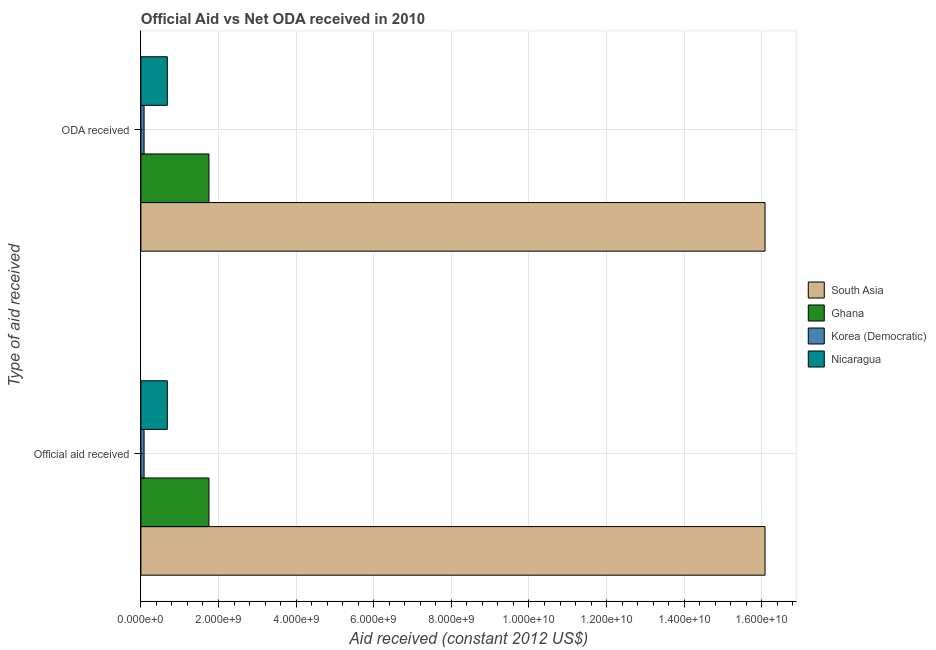How many different coloured bars are there?
Provide a succinct answer. 4. Are the number of bars per tick equal to the number of legend labels?
Provide a short and direct response. Yes. How many bars are there on the 1st tick from the top?
Give a very brief answer. 4. What is the label of the 2nd group of bars from the top?
Provide a succinct answer. Official aid received. What is the oda received in Nicaragua?
Your answer should be compact. 6.81e+08. Across all countries, what is the maximum official aid received?
Provide a succinct answer. 1.61e+1. Across all countries, what is the minimum oda received?
Provide a short and direct response. 8.22e+07. In which country was the oda received minimum?
Your answer should be very brief. Korea (Democratic). What is the total oda received in the graph?
Give a very brief answer. 1.86e+1. What is the difference between the official aid received in Ghana and that in Korea (Democratic)?
Give a very brief answer. 1.67e+09. What is the difference between the official aid received in Korea (Democratic) and the oda received in Nicaragua?
Offer a terse response. -5.99e+08. What is the average oda received per country?
Offer a terse response. 4.65e+09. What is the difference between the official aid received and oda received in Ghana?
Offer a very short reply. 0. What is the ratio of the oda received in Nicaragua to that in South Asia?
Keep it short and to the point. 0.04. In how many countries, is the official aid received greater than the average official aid received taken over all countries?
Offer a very short reply. 1. What does the 2nd bar from the top in ODA received represents?
Give a very brief answer. Korea (Democratic). How many countries are there in the graph?
Make the answer very short. 4. How many legend labels are there?
Keep it short and to the point. 4. What is the title of the graph?
Give a very brief answer. Official Aid vs Net ODA received in 2010 . What is the label or title of the X-axis?
Your answer should be very brief. Aid received (constant 2012 US$). What is the label or title of the Y-axis?
Ensure brevity in your answer.  Type of aid received. What is the Aid received (constant 2012 US$) in South Asia in Official aid received?
Your answer should be very brief. 1.61e+1. What is the Aid received (constant 2012 US$) of Ghana in Official aid received?
Offer a very short reply. 1.75e+09. What is the Aid received (constant 2012 US$) in Korea (Democratic) in Official aid received?
Keep it short and to the point. 8.22e+07. What is the Aid received (constant 2012 US$) in Nicaragua in Official aid received?
Give a very brief answer. 6.81e+08. What is the Aid received (constant 2012 US$) in South Asia in ODA received?
Offer a terse response. 1.61e+1. What is the Aid received (constant 2012 US$) of Ghana in ODA received?
Give a very brief answer. 1.75e+09. What is the Aid received (constant 2012 US$) in Korea (Democratic) in ODA received?
Make the answer very short. 8.22e+07. What is the Aid received (constant 2012 US$) in Nicaragua in ODA received?
Offer a very short reply. 6.81e+08. Across all Type of aid received, what is the maximum Aid received (constant 2012 US$) of South Asia?
Offer a terse response. 1.61e+1. Across all Type of aid received, what is the maximum Aid received (constant 2012 US$) of Ghana?
Keep it short and to the point. 1.75e+09. Across all Type of aid received, what is the maximum Aid received (constant 2012 US$) in Korea (Democratic)?
Your answer should be compact. 8.22e+07. Across all Type of aid received, what is the maximum Aid received (constant 2012 US$) in Nicaragua?
Give a very brief answer. 6.81e+08. Across all Type of aid received, what is the minimum Aid received (constant 2012 US$) in South Asia?
Provide a succinct answer. 1.61e+1. Across all Type of aid received, what is the minimum Aid received (constant 2012 US$) in Ghana?
Provide a succinct answer. 1.75e+09. Across all Type of aid received, what is the minimum Aid received (constant 2012 US$) in Korea (Democratic)?
Your response must be concise. 8.22e+07. Across all Type of aid received, what is the minimum Aid received (constant 2012 US$) in Nicaragua?
Provide a succinct answer. 6.81e+08. What is the total Aid received (constant 2012 US$) of South Asia in the graph?
Your answer should be compact. 3.22e+1. What is the total Aid received (constant 2012 US$) in Ghana in the graph?
Provide a succinct answer. 3.51e+09. What is the total Aid received (constant 2012 US$) of Korea (Democratic) in the graph?
Ensure brevity in your answer.  1.64e+08. What is the total Aid received (constant 2012 US$) of Nicaragua in the graph?
Offer a terse response. 1.36e+09. What is the difference between the Aid received (constant 2012 US$) in South Asia in Official aid received and that in ODA received?
Provide a short and direct response. 0. What is the difference between the Aid received (constant 2012 US$) of Korea (Democratic) in Official aid received and that in ODA received?
Offer a very short reply. 0. What is the difference between the Aid received (constant 2012 US$) of Nicaragua in Official aid received and that in ODA received?
Your answer should be compact. 0. What is the difference between the Aid received (constant 2012 US$) of South Asia in Official aid received and the Aid received (constant 2012 US$) of Ghana in ODA received?
Provide a short and direct response. 1.43e+1. What is the difference between the Aid received (constant 2012 US$) of South Asia in Official aid received and the Aid received (constant 2012 US$) of Korea (Democratic) in ODA received?
Offer a terse response. 1.60e+1. What is the difference between the Aid received (constant 2012 US$) of South Asia in Official aid received and the Aid received (constant 2012 US$) of Nicaragua in ODA received?
Ensure brevity in your answer.  1.54e+1. What is the difference between the Aid received (constant 2012 US$) in Ghana in Official aid received and the Aid received (constant 2012 US$) in Korea (Democratic) in ODA received?
Provide a short and direct response. 1.67e+09. What is the difference between the Aid received (constant 2012 US$) of Ghana in Official aid received and the Aid received (constant 2012 US$) of Nicaragua in ODA received?
Your answer should be compact. 1.07e+09. What is the difference between the Aid received (constant 2012 US$) of Korea (Democratic) in Official aid received and the Aid received (constant 2012 US$) of Nicaragua in ODA received?
Ensure brevity in your answer.  -5.99e+08. What is the average Aid received (constant 2012 US$) of South Asia per Type of aid received?
Make the answer very short. 1.61e+1. What is the average Aid received (constant 2012 US$) in Ghana per Type of aid received?
Ensure brevity in your answer.  1.75e+09. What is the average Aid received (constant 2012 US$) in Korea (Democratic) per Type of aid received?
Make the answer very short. 8.22e+07. What is the average Aid received (constant 2012 US$) of Nicaragua per Type of aid received?
Make the answer very short. 6.81e+08. What is the difference between the Aid received (constant 2012 US$) in South Asia and Aid received (constant 2012 US$) in Ghana in Official aid received?
Provide a short and direct response. 1.43e+1. What is the difference between the Aid received (constant 2012 US$) in South Asia and Aid received (constant 2012 US$) in Korea (Democratic) in Official aid received?
Your response must be concise. 1.60e+1. What is the difference between the Aid received (constant 2012 US$) in South Asia and Aid received (constant 2012 US$) in Nicaragua in Official aid received?
Your response must be concise. 1.54e+1. What is the difference between the Aid received (constant 2012 US$) of Ghana and Aid received (constant 2012 US$) of Korea (Democratic) in Official aid received?
Your answer should be compact. 1.67e+09. What is the difference between the Aid received (constant 2012 US$) in Ghana and Aid received (constant 2012 US$) in Nicaragua in Official aid received?
Your response must be concise. 1.07e+09. What is the difference between the Aid received (constant 2012 US$) of Korea (Democratic) and Aid received (constant 2012 US$) of Nicaragua in Official aid received?
Your answer should be very brief. -5.99e+08. What is the difference between the Aid received (constant 2012 US$) of South Asia and Aid received (constant 2012 US$) of Ghana in ODA received?
Your response must be concise. 1.43e+1. What is the difference between the Aid received (constant 2012 US$) in South Asia and Aid received (constant 2012 US$) in Korea (Democratic) in ODA received?
Provide a short and direct response. 1.60e+1. What is the difference between the Aid received (constant 2012 US$) of South Asia and Aid received (constant 2012 US$) of Nicaragua in ODA received?
Provide a succinct answer. 1.54e+1. What is the difference between the Aid received (constant 2012 US$) of Ghana and Aid received (constant 2012 US$) of Korea (Democratic) in ODA received?
Ensure brevity in your answer.  1.67e+09. What is the difference between the Aid received (constant 2012 US$) of Ghana and Aid received (constant 2012 US$) of Nicaragua in ODA received?
Offer a very short reply. 1.07e+09. What is the difference between the Aid received (constant 2012 US$) of Korea (Democratic) and Aid received (constant 2012 US$) of Nicaragua in ODA received?
Make the answer very short. -5.99e+08. What is the ratio of the Aid received (constant 2012 US$) in South Asia in Official aid received to that in ODA received?
Your answer should be compact. 1. What is the ratio of the Aid received (constant 2012 US$) of Ghana in Official aid received to that in ODA received?
Make the answer very short. 1. What is the ratio of the Aid received (constant 2012 US$) of Korea (Democratic) in Official aid received to that in ODA received?
Keep it short and to the point. 1. What is the difference between the highest and the second highest Aid received (constant 2012 US$) in South Asia?
Offer a terse response. 0. What is the difference between the highest and the second highest Aid received (constant 2012 US$) of Nicaragua?
Keep it short and to the point. 0. What is the difference between the highest and the lowest Aid received (constant 2012 US$) of South Asia?
Your answer should be very brief. 0. What is the difference between the highest and the lowest Aid received (constant 2012 US$) of Ghana?
Your answer should be very brief. 0. What is the difference between the highest and the lowest Aid received (constant 2012 US$) in Nicaragua?
Your answer should be very brief. 0. 